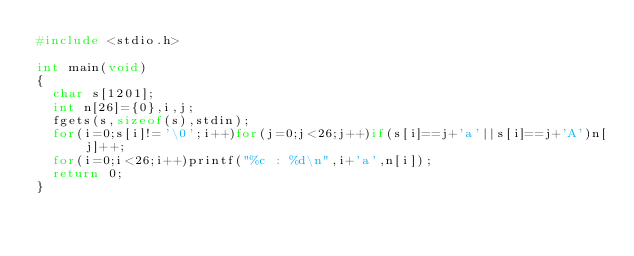<code> <loc_0><loc_0><loc_500><loc_500><_C_>#include <stdio.h>

int main(void)
{
	char s[1201];
	int n[26]={0},i,j;
	fgets(s,sizeof(s),stdin);
	for(i=0;s[i]!='\0';i++)for(j=0;j<26;j++)if(s[i]==j+'a'||s[i]==j+'A')n[j]++;
	for(i=0;i<26;i++)printf("%c : %d\n",i+'a',n[i]);
	return 0;
}
</code> 